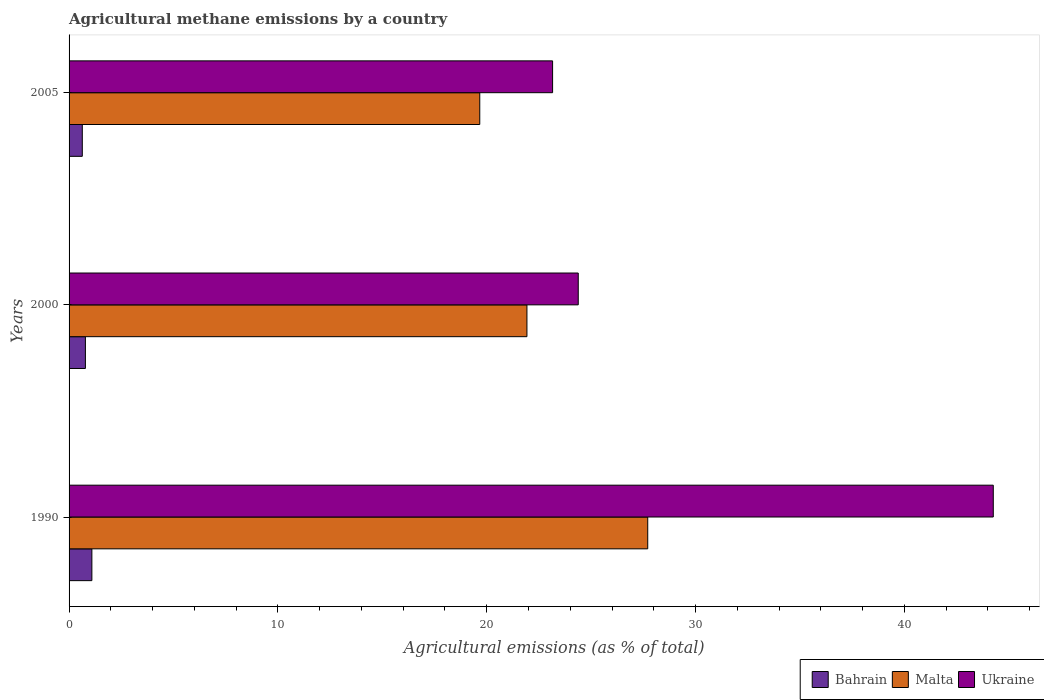How many groups of bars are there?
Keep it short and to the point. 3. Are the number of bars on each tick of the Y-axis equal?
Your response must be concise. Yes. What is the label of the 2nd group of bars from the top?
Your answer should be very brief. 2000. What is the amount of agricultural methane emitted in Malta in 2005?
Give a very brief answer. 19.67. Across all years, what is the maximum amount of agricultural methane emitted in Malta?
Provide a succinct answer. 27.71. Across all years, what is the minimum amount of agricultural methane emitted in Ukraine?
Your answer should be very brief. 23.15. In which year was the amount of agricultural methane emitted in Ukraine maximum?
Give a very brief answer. 1990. What is the total amount of agricultural methane emitted in Bahrain in the graph?
Your response must be concise. 2.51. What is the difference between the amount of agricultural methane emitted in Malta in 1990 and that in 2000?
Ensure brevity in your answer.  5.78. What is the difference between the amount of agricultural methane emitted in Malta in 2005 and the amount of agricultural methane emitted in Bahrain in 2000?
Give a very brief answer. 18.88. What is the average amount of agricultural methane emitted in Ukraine per year?
Offer a very short reply. 30.6. In the year 2000, what is the difference between the amount of agricultural methane emitted in Malta and amount of agricultural methane emitted in Bahrain?
Offer a very short reply. 21.14. In how many years, is the amount of agricultural methane emitted in Malta greater than 22 %?
Ensure brevity in your answer.  1. What is the ratio of the amount of agricultural methane emitted in Bahrain in 2000 to that in 2005?
Offer a very short reply. 1.23. Is the amount of agricultural methane emitted in Ukraine in 1990 less than that in 2000?
Provide a succinct answer. No. Is the difference between the amount of agricultural methane emitted in Malta in 1990 and 2000 greater than the difference between the amount of agricultural methane emitted in Bahrain in 1990 and 2000?
Your answer should be compact. Yes. What is the difference between the highest and the second highest amount of agricultural methane emitted in Bahrain?
Keep it short and to the point. 0.31. What is the difference between the highest and the lowest amount of agricultural methane emitted in Bahrain?
Offer a very short reply. 0.46. In how many years, is the amount of agricultural methane emitted in Malta greater than the average amount of agricultural methane emitted in Malta taken over all years?
Your answer should be very brief. 1. Is the sum of the amount of agricultural methane emitted in Bahrain in 1990 and 2000 greater than the maximum amount of agricultural methane emitted in Malta across all years?
Keep it short and to the point. No. What does the 3rd bar from the top in 2000 represents?
Make the answer very short. Bahrain. What does the 3rd bar from the bottom in 2000 represents?
Offer a terse response. Ukraine. How many bars are there?
Offer a terse response. 9. Are all the bars in the graph horizontal?
Keep it short and to the point. Yes. What is the difference between two consecutive major ticks on the X-axis?
Provide a succinct answer. 10. Are the values on the major ticks of X-axis written in scientific E-notation?
Give a very brief answer. No. Does the graph contain any zero values?
Ensure brevity in your answer.  No. Does the graph contain grids?
Make the answer very short. No. Where does the legend appear in the graph?
Give a very brief answer. Bottom right. How many legend labels are there?
Your answer should be compact. 3. What is the title of the graph?
Provide a short and direct response. Agricultural methane emissions by a country. Does "Turks and Caicos Islands" appear as one of the legend labels in the graph?
Provide a short and direct response. No. What is the label or title of the X-axis?
Your answer should be very brief. Agricultural emissions (as % of total). What is the Agricultural emissions (as % of total) in Bahrain in 1990?
Your answer should be very brief. 1.09. What is the Agricultural emissions (as % of total) of Malta in 1990?
Offer a very short reply. 27.71. What is the Agricultural emissions (as % of total) of Ukraine in 1990?
Provide a succinct answer. 44.25. What is the Agricultural emissions (as % of total) in Bahrain in 2000?
Provide a succinct answer. 0.78. What is the Agricultural emissions (as % of total) of Malta in 2000?
Offer a very short reply. 21.92. What is the Agricultural emissions (as % of total) of Ukraine in 2000?
Your answer should be very brief. 24.38. What is the Agricultural emissions (as % of total) in Bahrain in 2005?
Your answer should be compact. 0.63. What is the Agricultural emissions (as % of total) in Malta in 2005?
Ensure brevity in your answer.  19.67. What is the Agricultural emissions (as % of total) of Ukraine in 2005?
Your answer should be very brief. 23.15. Across all years, what is the maximum Agricultural emissions (as % of total) in Bahrain?
Give a very brief answer. 1.09. Across all years, what is the maximum Agricultural emissions (as % of total) of Malta?
Give a very brief answer. 27.71. Across all years, what is the maximum Agricultural emissions (as % of total) in Ukraine?
Give a very brief answer. 44.25. Across all years, what is the minimum Agricultural emissions (as % of total) of Bahrain?
Keep it short and to the point. 0.63. Across all years, what is the minimum Agricultural emissions (as % of total) of Malta?
Make the answer very short. 19.67. Across all years, what is the minimum Agricultural emissions (as % of total) in Ukraine?
Keep it short and to the point. 23.15. What is the total Agricultural emissions (as % of total) in Bahrain in the graph?
Provide a succinct answer. 2.51. What is the total Agricultural emissions (as % of total) of Malta in the graph?
Make the answer very short. 69.3. What is the total Agricultural emissions (as % of total) in Ukraine in the graph?
Provide a succinct answer. 91.79. What is the difference between the Agricultural emissions (as % of total) of Bahrain in 1990 and that in 2000?
Ensure brevity in your answer.  0.31. What is the difference between the Agricultural emissions (as % of total) in Malta in 1990 and that in 2000?
Give a very brief answer. 5.78. What is the difference between the Agricultural emissions (as % of total) of Ukraine in 1990 and that in 2000?
Give a very brief answer. 19.87. What is the difference between the Agricultural emissions (as % of total) in Bahrain in 1990 and that in 2005?
Ensure brevity in your answer.  0.46. What is the difference between the Agricultural emissions (as % of total) in Malta in 1990 and that in 2005?
Your answer should be compact. 8.04. What is the difference between the Agricultural emissions (as % of total) in Ukraine in 1990 and that in 2005?
Offer a terse response. 21.1. What is the difference between the Agricultural emissions (as % of total) of Bahrain in 2000 and that in 2005?
Provide a succinct answer. 0.15. What is the difference between the Agricultural emissions (as % of total) of Malta in 2000 and that in 2005?
Your answer should be very brief. 2.26. What is the difference between the Agricultural emissions (as % of total) of Ukraine in 2000 and that in 2005?
Offer a terse response. 1.23. What is the difference between the Agricultural emissions (as % of total) of Bahrain in 1990 and the Agricultural emissions (as % of total) of Malta in 2000?
Your response must be concise. -20.83. What is the difference between the Agricultural emissions (as % of total) of Bahrain in 1990 and the Agricultural emissions (as % of total) of Ukraine in 2000?
Offer a very short reply. -23.29. What is the difference between the Agricultural emissions (as % of total) in Malta in 1990 and the Agricultural emissions (as % of total) in Ukraine in 2000?
Ensure brevity in your answer.  3.33. What is the difference between the Agricultural emissions (as % of total) of Bahrain in 1990 and the Agricultural emissions (as % of total) of Malta in 2005?
Give a very brief answer. -18.57. What is the difference between the Agricultural emissions (as % of total) of Bahrain in 1990 and the Agricultural emissions (as % of total) of Ukraine in 2005?
Your answer should be compact. -22.06. What is the difference between the Agricultural emissions (as % of total) of Malta in 1990 and the Agricultural emissions (as % of total) of Ukraine in 2005?
Give a very brief answer. 4.56. What is the difference between the Agricultural emissions (as % of total) of Bahrain in 2000 and the Agricultural emissions (as % of total) of Malta in 2005?
Provide a succinct answer. -18.88. What is the difference between the Agricultural emissions (as % of total) of Bahrain in 2000 and the Agricultural emissions (as % of total) of Ukraine in 2005?
Ensure brevity in your answer.  -22.37. What is the difference between the Agricultural emissions (as % of total) of Malta in 2000 and the Agricultural emissions (as % of total) of Ukraine in 2005?
Offer a terse response. -1.23. What is the average Agricultural emissions (as % of total) of Bahrain per year?
Provide a short and direct response. 0.84. What is the average Agricultural emissions (as % of total) in Malta per year?
Ensure brevity in your answer.  23.1. What is the average Agricultural emissions (as % of total) of Ukraine per year?
Offer a very short reply. 30.6. In the year 1990, what is the difference between the Agricultural emissions (as % of total) in Bahrain and Agricultural emissions (as % of total) in Malta?
Keep it short and to the point. -26.62. In the year 1990, what is the difference between the Agricultural emissions (as % of total) in Bahrain and Agricultural emissions (as % of total) in Ukraine?
Make the answer very short. -43.16. In the year 1990, what is the difference between the Agricultural emissions (as % of total) of Malta and Agricultural emissions (as % of total) of Ukraine?
Keep it short and to the point. -16.55. In the year 2000, what is the difference between the Agricultural emissions (as % of total) in Bahrain and Agricultural emissions (as % of total) in Malta?
Give a very brief answer. -21.14. In the year 2000, what is the difference between the Agricultural emissions (as % of total) of Bahrain and Agricultural emissions (as % of total) of Ukraine?
Keep it short and to the point. -23.6. In the year 2000, what is the difference between the Agricultural emissions (as % of total) of Malta and Agricultural emissions (as % of total) of Ukraine?
Your answer should be compact. -2.46. In the year 2005, what is the difference between the Agricultural emissions (as % of total) in Bahrain and Agricultural emissions (as % of total) in Malta?
Your answer should be very brief. -19.03. In the year 2005, what is the difference between the Agricultural emissions (as % of total) in Bahrain and Agricultural emissions (as % of total) in Ukraine?
Ensure brevity in your answer.  -22.52. In the year 2005, what is the difference between the Agricultural emissions (as % of total) in Malta and Agricultural emissions (as % of total) in Ukraine?
Provide a short and direct response. -3.49. What is the ratio of the Agricultural emissions (as % of total) of Bahrain in 1990 to that in 2000?
Make the answer very short. 1.4. What is the ratio of the Agricultural emissions (as % of total) in Malta in 1990 to that in 2000?
Your answer should be compact. 1.26. What is the ratio of the Agricultural emissions (as % of total) in Ukraine in 1990 to that in 2000?
Provide a succinct answer. 1.82. What is the ratio of the Agricultural emissions (as % of total) of Bahrain in 1990 to that in 2005?
Your answer should be compact. 1.72. What is the ratio of the Agricultural emissions (as % of total) of Malta in 1990 to that in 2005?
Provide a short and direct response. 1.41. What is the ratio of the Agricultural emissions (as % of total) in Ukraine in 1990 to that in 2005?
Provide a succinct answer. 1.91. What is the ratio of the Agricultural emissions (as % of total) of Bahrain in 2000 to that in 2005?
Offer a terse response. 1.23. What is the ratio of the Agricultural emissions (as % of total) in Malta in 2000 to that in 2005?
Provide a short and direct response. 1.11. What is the ratio of the Agricultural emissions (as % of total) of Ukraine in 2000 to that in 2005?
Offer a terse response. 1.05. What is the difference between the highest and the second highest Agricultural emissions (as % of total) of Bahrain?
Your answer should be very brief. 0.31. What is the difference between the highest and the second highest Agricultural emissions (as % of total) in Malta?
Make the answer very short. 5.78. What is the difference between the highest and the second highest Agricultural emissions (as % of total) of Ukraine?
Offer a terse response. 19.87. What is the difference between the highest and the lowest Agricultural emissions (as % of total) in Bahrain?
Provide a short and direct response. 0.46. What is the difference between the highest and the lowest Agricultural emissions (as % of total) in Malta?
Offer a very short reply. 8.04. What is the difference between the highest and the lowest Agricultural emissions (as % of total) of Ukraine?
Make the answer very short. 21.1. 